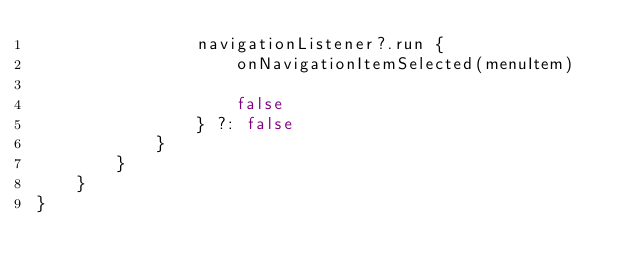<code> <loc_0><loc_0><loc_500><loc_500><_Kotlin_>                navigationListener?.run {
                    onNavigationItemSelected(menuItem)

                    false
                } ?: false
            }
        }
    }
}</code> 